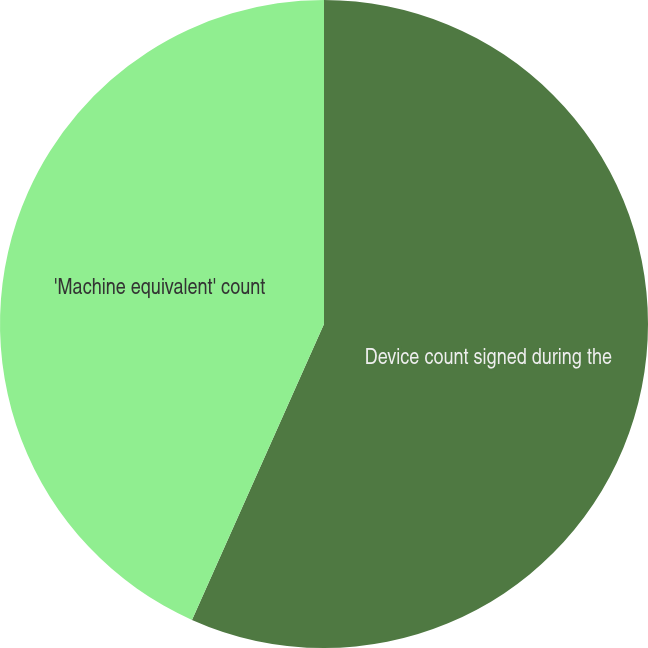Convert chart. <chart><loc_0><loc_0><loc_500><loc_500><pie_chart><fcel>Device count signed during the<fcel>'Machine equivalent' count<nl><fcel>56.68%<fcel>43.32%<nl></chart> 